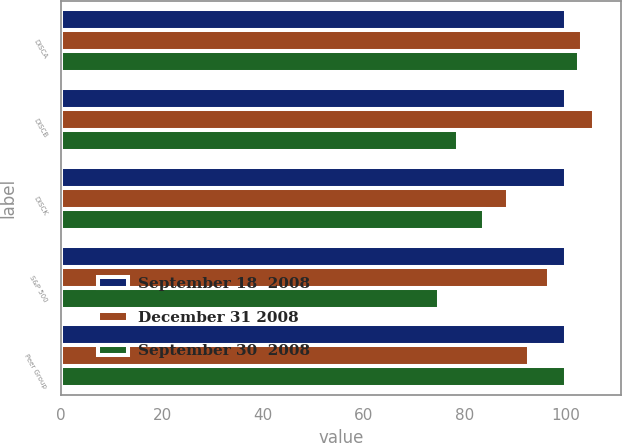Convert chart. <chart><loc_0><loc_0><loc_500><loc_500><stacked_bar_chart><ecel><fcel>DISCA<fcel>DISCB<fcel>DISCK<fcel>S&P 500<fcel>Peer Group<nl><fcel>September 18  2008<fcel>100<fcel>100<fcel>100<fcel>100<fcel>100<nl><fcel>December 31 2008<fcel>103.19<fcel>105.54<fcel>88.5<fcel>96.54<fcel>92.67<nl><fcel>September 30  2008<fcel>102.53<fcel>78.53<fcel>83.69<fcel>74.86<fcel>100<nl></chart> 